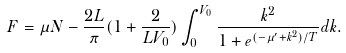<formula> <loc_0><loc_0><loc_500><loc_500>F = \mu N - \frac { 2 L } { \pi } ( 1 + \frac { 2 } { L V _ { 0 } } ) \int _ { 0 } ^ { V _ { 0 } } \frac { k ^ { 2 } } { 1 + e ^ { ( - \mu ^ { \prime } + k ^ { 2 } ) / T } } d k .</formula> 